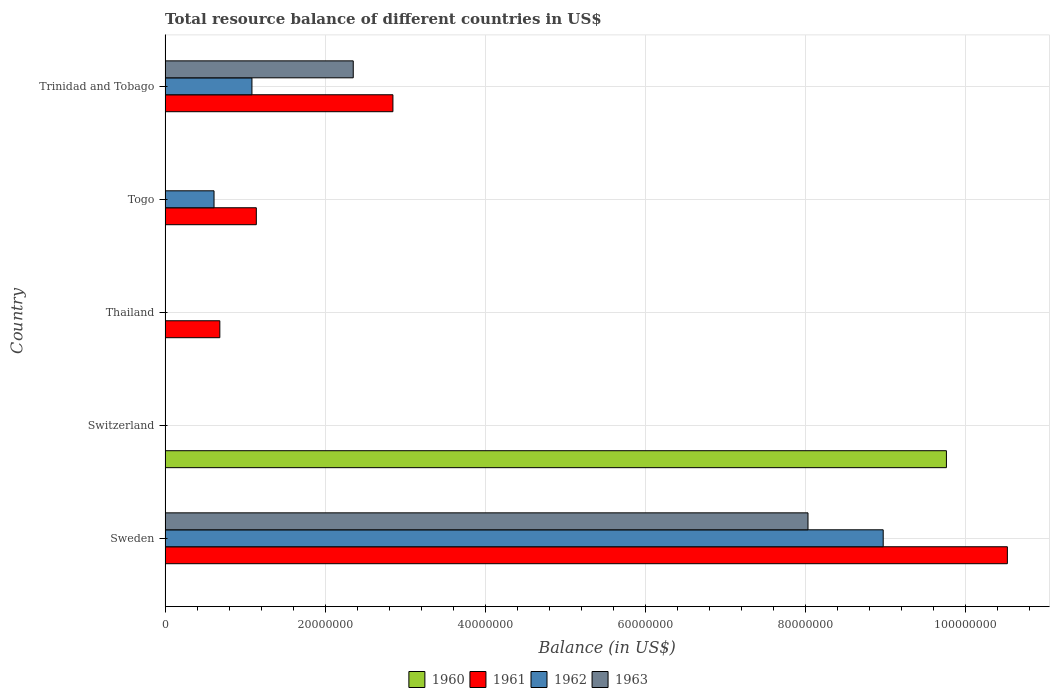Are the number of bars on each tick of the Y-axis equal?
Make the answer very short. No. How many bars are there on the 2nd tick from the top?
Your response must be concise. 2. How many bars are there on the 2nd tick from the bottom?
Provide a succinct answer. 1. What is the label of the 2nd group of bars from the top?
Make the answer very short. Togo. What is the total resource balance in 1962 in Thailand?
Offer a terse response. 0. Across all countries, what is the maximum total resource balance in 1963?
Your answer should be very brief. 8.03e+07. Across all countries, what is the minimum total resource balance in 1960?
Your response must be concise. 0. What is the total total resource balance in 1961 in the graph?
Your answer should be compact. 1.52e+08. What is the difference between the total resource balance in 1961 in Togo and that in Trinidad and Tobago?
Your answer should be very brief. -1.71e+07. What is the difference between the total resource balance in 1963 in Sweden and the total resource balance in 1962 in Thailand?
Ensure brevity in your answer.  8.03e+07. What is the average total resource balance in 1960 per country?
Provide a short and direct response. 1.95e+07. What is the difference between the total resource balance in 1961 and total resource balance in 1962 in Togo?
Your response must be concise. 5.29e+06. In how many countries, is the total resource balance in 1960 greater than 44000000 US$?
Provide a succinct answer. 1. What is the ratio of the total resource balance in 1961 in Sweden to that in Trinidad and Tobago?
Offer a very short reply. 3.7. Is the total resource balance in 1962 in Sweden less than that in Trinidad and Tobago?
Offer a very short reply. No. What is the difference between the highest and the second highest total resource balance in 1961?
Provide a succinct answer. 7.68e+07. What is the difference between the highest and the lowest total resource balance in 1960?
Your answer should be very brief. 9.76e+07. Is the sum of the total resource balance in 1961 in Togo and Trinidad and Tobago greater than the maximum total resource balance in 1960 across all countries?
Offer a very short reply. No. Is it the case that in every country, the sum of the total resource balance in 1962 and total resource balance in 1961 is greater than the total resource balance in 1963?
Offer a terse response. No. What is the difference between two consecutive major ticks on the X-axis?
Offer a terse response. 2.00e+07. Are the values on the major ticks of X-axis written in scientific E-notation?
Ensure brevity in your answer.  No. Does the graph contain grids?
Ensure brevity in your answer.  Yes. Where does the legend appear in the graph?
Make the answer very short. Bottom center. How many legend labels are there?
Provide a short and direct response. 4. How are the legend labels stacked?
Provide a short and direct response. Horizontal. What is the title of the graph?
Give a very brief answer. Total resource balance of different countries in US$. What is the label or title of the X-axis?
Make the answer very short. Balance (in US$). What is the Balance (in US$) of 1960 in Sweden?
Provide a short and direct response. 0. What is the Balance (in US$) in 1961 in Sweden?
Give a very brief answer. 1.05e+08. What is the Balance (in US$) in 1962 in Sweden?
Provide a succinct answer. 8.97e+07. What is the Balance (in US$) of 1963 in Sweden?
Keep it short and to the point. 8.03e+07. What is the Balance (in US$) in 1960 in Switzerland?
Your answer should be very brief. 9.76e+07. What is the Balance (in US$) in 1961 in Switzerland?
Your answer should be compact. 0. What is the Balance (in US$) of 1962 in Switzerland?
Provide a short and direct response. 0. What is the Balance (in US$) of 1961 in Thailand?
Your answer should be compact. 6.84e+06. What is the Balance (in US$) in 1961 in Togo?
Your response must be concise. 1.14e+07. What is the Balance (in US$) of 1962 in Togo?
Give a very brief answer. 6.11e+06. What is the Balance (in US$) of 1963 in Togo?
Offer a terse response. 0. What is the Balance (in US$) in 1960 in Trinidad and Tobago?
Your response must be concise. 0. What is the Balance (in US$) of 1961 in Trinidad and Tobago?
Give a very brief answer. 2.85e+07. What is the Balance (in US$) in 1962 in Trinidad and Tobago?
Offer a terse response. 1.08e+07. What is the Balance (in US$) in 1963 in Trinidad and Tobago?
Your answer should be compact. 2.35e+07. Across all countries, what is the maximum Balance (in US$) in 1960?
Keep it short and to the point. 9.76e+07. Across all countries, what is the maximum Balance (in US$) of 1961?
Make the answer very short. 1.05e+08. Across all countries, what is the maximum Balance (in US$) in 1962?
Offer a very short reply. 8.97e+07. Across all countries, what is the maximum Balance (in US$) of 1963?
Make the answer very short. 8.03e+07. Across all countries, what is the minimum Balance (in US$) in 1960?
Ensure brevity in your answer.  0. Across all countries, what is the minimum Balance (in US$) in 1962?
Offer a very short reply. 0. Across all countries, what is the minimum Balance (in US$) of 1963?
Your answer should be compact. 0. What is the total Balance (in US$) in 1960 in the graph?
Your answer should be compact. 9.76e+07. What is the total Balance (in US$) of 1961 in the graph?
Give a very brief answer. 1.52e+08. What is the total Balance (in US$) in 1962 in the graph?
Offer a very short reply. 1.07e+08. What is the total Balance (in US$) of 1963 in the graph?
Provide a short and direct response. 1.04e+08. What is the difference between the Balance (in US$) in 1961 in Sweden and that in Thailand?
Your response must be concise. 9.84e+07. What is the difference between the Balance (in US$) in 1961 in Sweden and that in Togo?
Your answer should be very brief. 9.38e+07. What is the difference between the Balance (in US$) of 1962 in Sweden and that in Togo?
Offer a very short reply. 8.36e+07. What is the difference between the Balance (in US$) in 1961 in Sweden and that in Trinidad and Tobago?
Provide a short and direct response. 7.68e+07. What is the difference between the Balance (in US$) of 1962 in Sweden and that in Trinidad and Tobago?
Your response must be concise. 7.89e+07. What is the difference between the Balance (in US$) of 1963 in Sweden and that in Trinidad and Tobago?
Provide a succinct answer. 5.68e+07. What is the difference between the Balance (in US$) of 1961 in Thailand and that in Togo?
Make the answer very short. -4.56e+06. What is the difference between the Balance (in US$) of 1961 in Thailand and that in Trinidad and Tobago?
Ensure brevity in your answer.  -2.16e+07. What is the difference between the Balance (in US$) of 1961 in Togo and that in Trinidad and Tobago?
Make the answer very short. -1.71e+07. What is the difference between the Balance (in US$) of 1962 in Togo and that in Trinidad and Tobago?
Ensure brevity in your answer.  -4.74e+06. What is the difference between the Balance (in US$) in 1961 in Sweden and the Balance (in US$) in 1962 in Togo?
Keep it short and to the point. 9.91e+07. What is the difference between the Balance (in US$) of 1961 in Sweden and the Balance (in US$) of 1962 in Trinidad and Tobago?
Your answer should be compact. 9.44e+07. What is the difference between the Balance (in US$) of 1961 in Sweden and the Balance (in US$) of 1963 in Trinidad and Tobago?
Keep it short and to the point. 8.17e+07. What is the difference between the Balance (in US$) of 1962 in Sweden and the Balance (in US$) of 1963 in Trinidad and Tobago?
Offer a very short reply. 6.62e+07. What is the difference between the Balance (in US$) in 1960 in Switzerland and the Balance (in US$) in 1961 in Thailand?
Offer a very short reply. 9.08e+07. What is the difference between the Balance (in US$) in 1960 in Switzerland and the Balance (in US$) in 1961 in Togo?
Offer a terse response. 8.62e+07. What is the difference between the Balance (in US$) in 1960 in Switzerland and the Balance (in US$) in 1962 in Togo?
Provide a short and direct response. 9.15e+07. What is the difference between the Balance (in US$) of 1960 in Switzerland and the Balance (in US$) of 1961 in Trinidad and Tobago?
Offer a terse response. 6.92e+07. What is the difference between the Balance (in US$) of 1960 in Switzerland and the Balance (in US$) of 1962 in Trinidad and Tobago?
Offer a terse response. 8.68e+07. What is the difference between the Balance (in US$) in 1960 in Switzerland and the Balance (in US$) in 1963 in Trinidad and Tobago?
Your response must be concise. 7.41e+07. What is the difference between the Balance (in US$) in 1961 in Thailand and the Balance (in US$) in 1962 in Togo?
Your answer should be compact. 7.25e+05. What is the difference between the Balance (in US$) in 1961 in Thailand and the Balance (in US$) in 1962 in Trinidad and Tobago?
Your answer should be compact. -4.01e+06. What is the difference between the Balance (in US$) in 1961 in Thailand and the Balance (in US$) in 1963 in Trinidad and Tobago?
Keep it short and to the point. -1.67e+07. What is the difference between the Balance (in US$) of 1961 in Togo and the Balance (in US$) of 1962 in Trinidad and Tobago?
Your response must be concise. 5.50e+05. What is the difference between the Balance (in US$) of 1961 in Togo and the Balance (in US$) of 1963 in Trinidad and Tobago?
Offer a terse response. -1.21e+07. What is the difference between the Balance (in US$) in 1962 in Togo and the Balance (in US$) in 1963 in Trinidad and Tobago?
Offer a terse response. -1.74e+07. What is the average Balance (in US$) in 1960 per country?
Your answer should be very brief. 1.95e+07. What is the average Balance (in US$) of 1961 per country?
Your answer should be compact. 3.04e+07. What is the average Balance (in US$) of 1962 per country?
Offer a terse response. 2.13e+07. What is the average Balance (in US$) in 1963 per country?
Provide a short and direct response. 2.08e+07. What is the difference between the Balance (in US$) of 1961 and Balance (in US$) of 1962 in Sweden?
Your answer should be compact. 1.55e+07. What is the difference between the Balance (in US$) of 1961 and Balance (in US$) of 1963 in Sweden?
Your answer should be compact. 2.49e+07. What is the difference between the Balance (in US$) in 1962 and Balance (in US$) in 1963 in Sweden?
Provide a succinct answer. 9.40e+06. What is the difference between the Balance (in US$) of 1961 and Balance (in US$) of 1962 in Togo?
Provide a succinct answer. 5.29e+06. What is the difference between the Balance (in US$) of 1961 and Balance (in US$) of 1962 in Trinidad and Tobago?
Offer a very short reply. 1.76e+07. What is the difference between the Balance (in US$) of 1961 and Balance (in US$) of 1963 in Trinidad and Tobago?
Your response must be concise. 4.96e+06. What is the difference between the Balance (in US$) of 1962 and Balance (in US$) of 1963 in Trinidad and Tobago?
Offer a terse response. -1.27e+07. What is the ratio of the Balance (in US$) of 1961 in Sweden to that in Thailand?
Keep it short and to the point. 15.39. What is the ratio of the Balance (in US$) of 1961 in Sweden to that in Togo?
Ensure brevity in your answer.  9.23. What is the ratio of the Balance (in US$) of 1962 in Sweden to that in Togo?
Your response must be concise. 14.68. What is the ratio of the Balance (in US$) in 1961 in Sweden to that in Trinidad and Tobago?
Your answer should be compact. 3.7. What is the ratio of the Balance (in US$) in 1962 in Sweden to that in Trinidad and Tobago?
Provide a succinct answer. 8.27. What is the ratio of the Balance (in US$) of 1963 in Sweden to that in Trinidad and Tobago?
Offer a terse response. 3.42. What is the ratio of the Balance (in US$) of 1961 in Thailand to that in Togo?
Offer a very short reply. 0.6. What is the ratio of the Balance (in US$) of 1961 in Thailand to that in Trinidad and Tobago?
Your answer should be compact. 0.24. What is the ratio of the Balance (in US$) of 1961 in Togo to that in Trinidad and Tobago?
Offer a very short reply. 0.4. What is the ratio of the Balance (in US$) in 1962 in Togo to that in Trinidad and Tobago?
Your answer should be very brief. 0.56. What is the difference between the highest and the second highest Balance (in US$) of 1961?
Your response must be concise. 7.68e+07. What is the difference between the highest and the second highest Balance (in US$) of 1962?
Give a very brief answer. 7.89e+07. What is the difference between the highest and the lowest Balance (in US$) of 1960?
Your answer should be very brief. 9.76e+07. What is the difference between the highest and the lowest Balance (in US$) of 1961?
Give a very brief answer. 1.05e+08. What is the difference between the highest and the lowest Balance (in US$) in 1962?
Provide a succinct answer. 8.97e+07. What is the difference between the highest and the lowest Balance (in US$) of 1963?
Provide a succinct answer. 8.03e+07. 